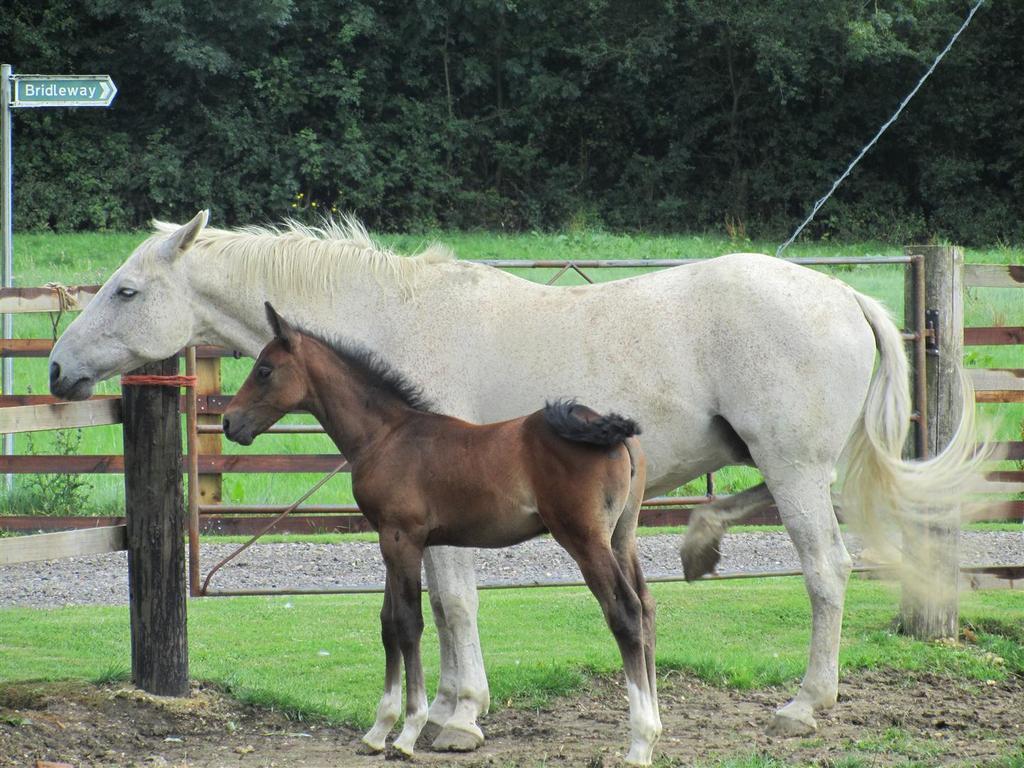In one or two sentences, can you explain what this image depicts? In this image in the center there are two horses, and in the background there is a fence. At the bottom there is mud and grass, and in the background there are trees wire. On the left side there is pole and board, on the board there is text. 